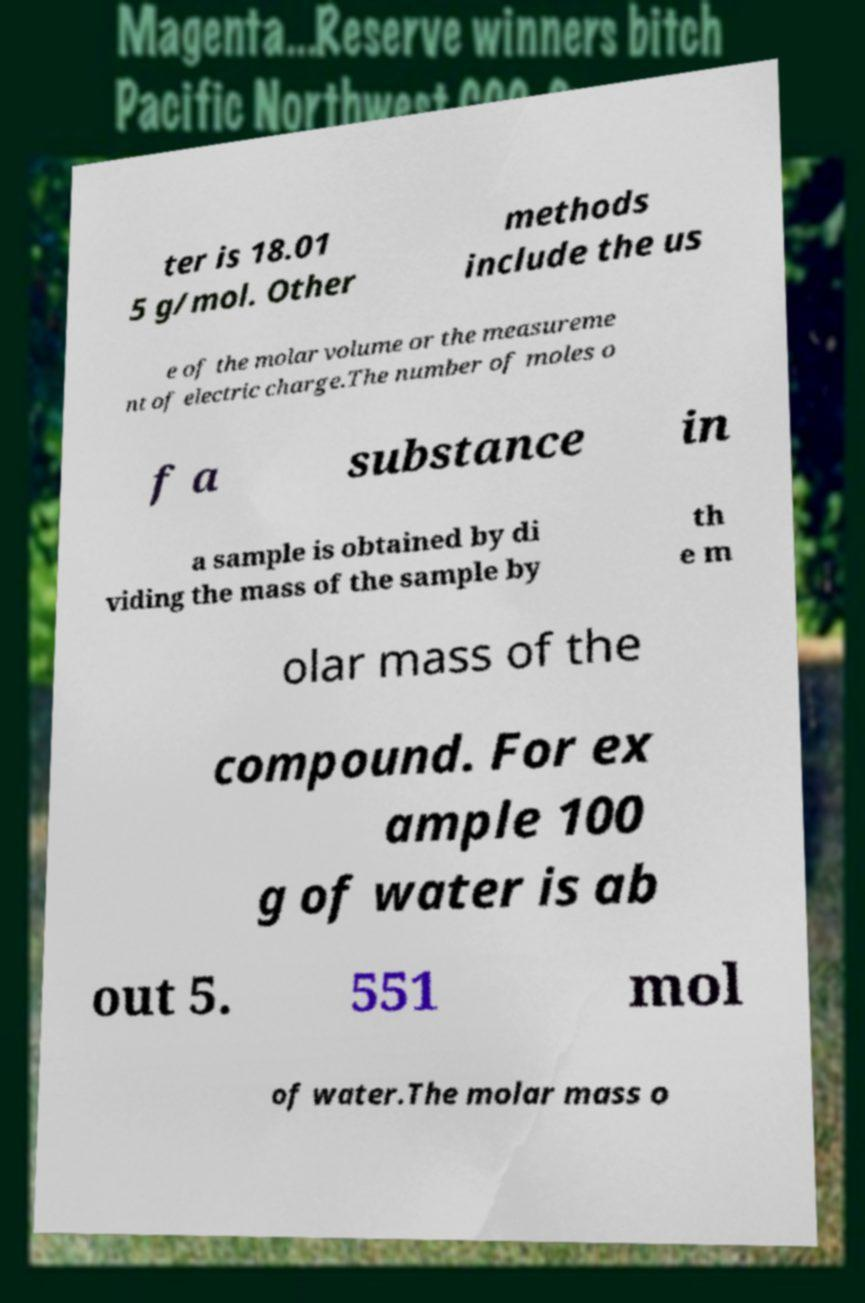Can you accurately transcribe the text from the provided image for me? ter is 18.01 5 g/mol. Other methods include the us e of the molar volume or the measureme nt of electric charge.The number of moles o f a substance in a sample is obtained by di viding the mass of the sample by th e m olar mass of the compound. For ex ample 100 g of water is ab out 5. 551 mol of water.The molar mass o 